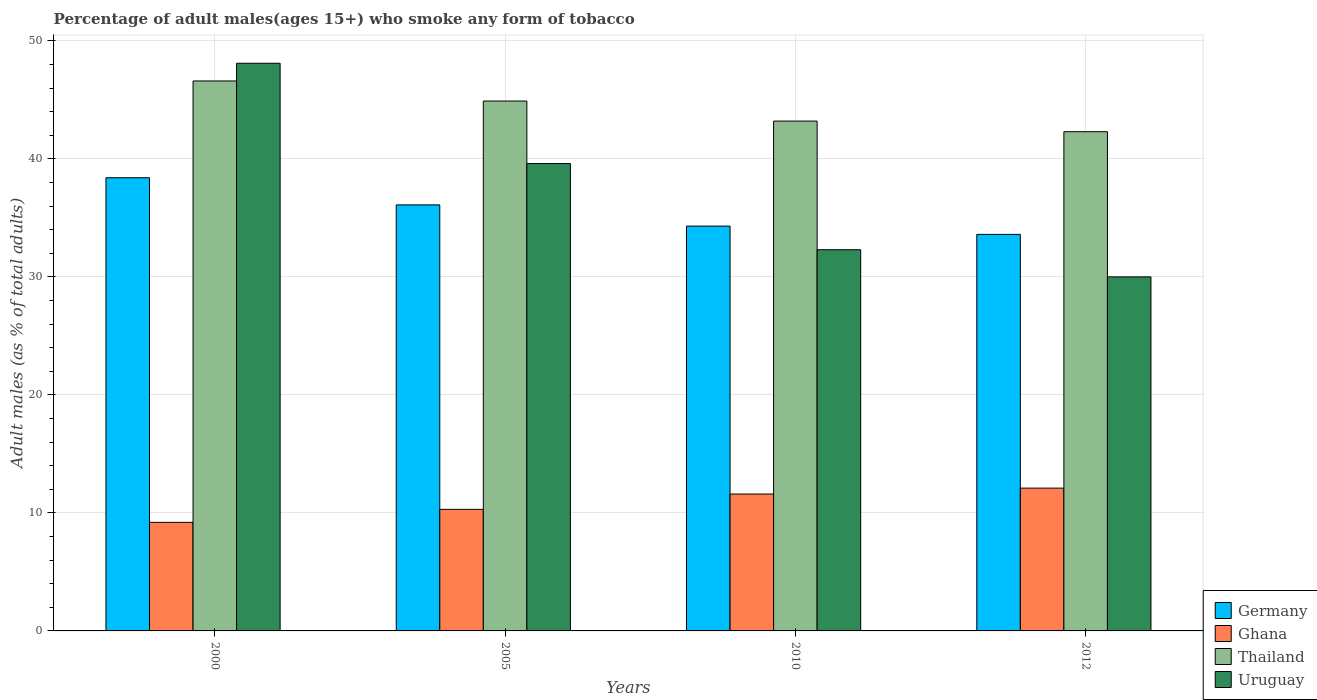How many different coloured bars are there?
Your answer should be very brief. 4. Are the number of bars per tick equal to the number of legend labels?
Your response must be concise. Yes. How many bars are there on the 1st tick from the left?
Offer a very short reply. 4. How many bars are there on the 1st tick from the right?
Make the answer very short. 4. In how many cases, is the number of bars for a given year not equal to the number of legend labels?
Keep it short and to the point. 0. What is the percentage of adult males who smoke in Germany in 2005?
Your answer should be very brief. 36.1. Across all years, what is the maximum percentage of adult males who smoke in Ghana?
Ensure brevity in your answer.  12.1. Across all years, what is the minimum percentage of adult males who smoke in Germany?
Make the answer very short. 33.6. What is the total percentage of adult males who smoke in Germany in the graph?
Offer a terse response. 142.4. What is the difference between the percentage of adult males who smoke in Uruguay in 2000 and that in 2005?
Make the answer very short. 8.5. What is the difference between the percentage of adult males who smoke in Uruguay in 2000 and the percentage of adult males who smoke in Thailand in 2012?
Keep it short and to the point. 5.8. What is the average percentage of adult males who smoke in Ghana per year?
Provide a short and direct response. 10.8. In the year 2000, what is the difference between the percentage of adult males who smoke in Thailand and percentage of adult males who smoke in Ghana?
Offer a very short reply. 37.4. In how many years, is the percentage of adult males who smoke in Thailand greater than 20 %?
Ensure brevity in your answer.  4. What is the ratio of the percentage of adult males who smoke in Germany in 2010 to that in 2012?
Ensure brevity in your answer.  1.02. Is the percentage of adult males who smoke in Ghana in 2000 less than that in 2010?
Your answer should be compact. Yes. Is the difference between the percentage of adult males who smoke in Thailand in 2005 and 2010 greater than the difference between the percentage of adult males who smoke in Ghana in 2005 and 2010?
Make the answer very short. Yes. What is the difference between the highest and the lowest percentage of adult males who smoke in Thailand?
Offer a terse response. 4.3. In how many years, is the percentage of adult males who smoke in Ghana greater than the average percentage of adult males who smoke in Ghana taken over all years?
Ensure brevity in your answer.  2. Is the sum of the percentage of adult males who smoke in Germany in 2005 and 2012 greater than the maximum percentage of adult males who smoke in Uruguay across all years?
Offer a terse response. Yes. Is it the case that in every year, the sum of the percentage of adult males who smoke in Uruguay and percentage of adult males who smoke in Thailand is greater than the sum of percentage of adult males who smoke in Ghana and percentage of adult males who smoke in Germany?
Your response must be concise. Yes. What does the 2nd bar from the right in 2005 represents?
Ensure brevity in your answer.  Thailand. Is it the case that in every year, the sum of the percentage of adult males who smoke in Germany and percentage of adult males who smoke in Thailand is greater than the percentage of adult males who smoke in Uruguay?
Give a very brief answer. Yes. How many bars are there?
Offer a terse response. 16. What is the difference between two consecutive major ticks on the Y-axis?
Provide a succinct answer. 10. Are the values on the major ticks of Y-axis written in scientific E-notation?
Your answer should be compact. No. Where does the legend appear in the graph?
Keep it short and to the point. Bottom right. What is the title of the graph?
Your response must be concise. Percentage of adult males(ages 15+) who smoke any form of tobacco. What is the label or title of the Y-axis?
Your answer should be compact. Adult males (as % of total adults). What is the Adult males (as % of total adults) of Germany in 2000?
Make the answer very short. 38.4. What is the Adult males (as % of total adults) in Ghana in 2000?
Provide a short and direct response. 9.2. What is the Adult males (as % of total adults) of Thailand in 2000?
Offer a terse response. 46.6. What is the Adult males (as % of total adults) in Uruguay in 2000?
Provide a short and direct response. 48.1. What is the Adult males (as % of total adults) of Germany in 2005?
Your answer should be very brief. 36.1. What is the Adult males (as % of total adults) of Thailand in 2005?
Offer a very short reply. 44.9. What is the Adult males (as % of total adults) of Uruguay in 2005?
Ensure brevity in your answer.  39.6. What is the Adult males (as % of total adults) of Germany in 2010?
Your answer should be very brief. 34.3. What is the Adult males (as % of total adults) in Thailand in 2010?
Give a very brief answer. 43.2. What is the Adult males (as % of total adults) of Uruguay in 2010?
Offer a very short reply. 32.3. What is the Adult males (as % of total adults) of Germany in 2012?
Keep it short and to the point. 33.6. What is the Adult males (as % of total adults) in Thailand in 2012?
Your answer should be compact. 42.3. Across all years, what is the maximum Adult males (as % of total adults) of Germany?
Offer a very short reply. 38.4. Across all years, what is the maximum Adult males (as % of total adults) of Ghana?
Offer a very short reply. 12.1. Across all years, what is the maximum Adult males (as % of total adults) of Thailand?
Your answer should be very brief. 46.6. Across all years, what is the maximum Adult males (as % of total adults) of Uruguay?
Provide a short and direct response. 48.1. Across all years, what is the minimum Adult males (as % of total adults) in Germany?
Your response must be concise. 33.6. Across all years, what is the minimum Adult males (as % of total adults) of Thailand?
Make the answer very short. 42.3. What is the total Adult males (as % of total adults) in Germany in the graph?
Your answer should be compact. 142.4. What is the total Adult males (as % of total adults) of Ghana in the graph?
Offer a very short reply. 43.2. What is the total Adult males (as % of total adults) in Thailand in the graph?
Offer a terse response. 177. What is the total Adult males (as % of total adults) of Uruguay in the graph?
Give a very brief answer. 150. What is the difference between the Adult males (as % of total adults) in Ghana in 2000 and that in 2005?
Provide a succinct answer. -1.1. What is the difference between the Adult males (as % of total adults) of Germany in 2000 and that in 2010?
Offer a terse response. 4.1. What is the difference between the Adult males (as % of total adults) of Ghana in 2000 and that in 2010?
Offer a terse response. -2.4. What is the difference between the Adult males (as % of total adults) of Thailand in 2000 and that in 2010?
Keep it short and to the point. 3.4. What is the difference between the Adult males (as % of total adults) of Uruguay in 2000 and that in 2010?
Your answer should be compact. 15.8. What is the difference between the Adult males (as % of total adults) in Germany in 2000 and that in 2012?
Your answer should be compact. 4.8. What is the difference between the Adult males (as % of total adults) of Ghana in 2000 and that in 2012?
Provide a succinct answer. -2.9. What is the difference between the Adult males (as % of total adults) in Thailand in 2000 and that in 2012?
Your answer should be very brief. 4.3. What is the difference between the Adult males (as % of total adults) in Germany in 2005 and that in 2010?
Provide a succinct answer. 1.8. What is the difference between the Adult males (as % of total adults) of Thailand in 2005 and that in 2010?
Provide a succinct answer. 1.7. What is the difference between the Adult males (as % of total adults) in Uruguay in 2005 and that in 2010?
Offer a very short reply. 7.3. What is the difference between the Adult males (as % of total adults) of Germany in 2005 and that in 2012?
Offer a very short reply. 2.5. What is the difference between the Adult males (as % of total adults) of Ghana in 2005 and that in 2012?
Make the answer very short. -1.8. What is the difference between the Adult males (as % of total adults) of Germany in 2010 and that in 2012?
Provide a succinct answer. 0.7. What is the difference between the Adult males (as % of total adults) in Uruguay in 2010 and that in 2012?
Give a very brief answer. 2.3. What is the difference between the Adult males (as % of total adults) of Germany in 2000 and the Adult males (as % of total adults) of Ghana in 2005?
Ensure brevity in your answer.  28.1. What is the difference between the Adult males (as % of total adults) of Ghana in 2000 and the Adult males (as % of total adults) of Thailand in 2005?
Your answer should be compact. -35.7. What is the difference between the Adult males (as % of total adults) of Ghana in 2000 and the Adult males (as % of total adults) of Uruguay in 2005?
Give a very brief answer. -30.4. What is the difference between the Adult males (as % of total adults) of Thailand in 2000 and the Adult males (as % of total adults) of Uruguay in 2005?
Offer a terse response. 7. What is the difference between the Adult males (as % of total adults) of Germany in 2000 and the Adult males (as % of total adults) of Ghana in 2010?
Provide a succinct answer. 26.8. What is the difference between the Adult males (as % of total adults) in Germany in 2000 and the Adult males (as % of total adults) in Thailand in 2010?
Give a very brief answer. -4.8. What is the difference between the Adult males (as % of total adults) of Germany in 2000 and the Adult males (as % of total adults) of Uruguay in 2010?
Provide a succinct answer. 6.1. What is the difference between the Adult males (as % of total adults) in Ghana in 2000 and the Adult males (as % of total adults) in Thailand in 2010?
Provide a short and direct response. -34. What is the difference between the Adult males (as % of total adults) in Ghana in 2000 and the Adult males (as % of total adults) in Uruguay in 2010?
Provide a short and direct response. -23.1. What is the difference between the Adult males (as % of total adults) of Germany in 2000 and the Adult males (as % of total adults) of Ghana in 2012?
Keep it short and to the point. 26.3. What is the difference between the Adult males (as % of total adults) of Germany in 2000 and the Adult males (as % of total adults) of Uruguay in 2012?
Your response must be concise. 8.4. What is the difference between the Adult males (as % of total adults) of Ghana in 2000 and the Adult males (as % of total adults) of Thailand in 2012?
Keep it short and to the point. -33.1. What is the difference between the Adult males (as % of total adults) of Ghana in 2000 and the Adult males (as % of total adults) of Uruguay in 2012?
Ensure brevity in your answer.  -20.8. What is the difference between the Adult males (as % of total adults) in Thailand in 2000 and the Adult males (as % of total adults) in Uruguay in 2012?
Your answer should be compact. 16.6. What is the difference between the Adult males (as % of total adults) of Germany in 2005 and the Adult males (as % of total adults) of Ghana in 2010?
Give a very brief answer. 24.5. What is the difference between the Adult males (as % of total adults) of Germany in 2005 and the Adult males (as % of total adults) of Uruguay in 2010?
Keep it short and to the point. 3.8. What is the difference between the Adult males (as % of total adults) in Ghana in 2005 and the Adult males (as % of total adults) in Thailand in 2010?
Give a very brief answer. -32.9. What is the difference between the Adult males (as % of total adults) in Ghana in 2005 and the Adult males (as % of total adults) in Uruguay in 2010?
Provide a short and direct response. -22. What is the difference between the Adult males (as % of total adults) in Thailand in 2005 and the Adult males (as % of total adults) in Uruguay in 2010?
Keep it short and to the point. 12.6. What is the difference between the Adult males (as % of total adults) of Germany in 2005 and the Adult males (as % of total adults) of Ghana in 2012?
Give a very brief answer. 24. What is the difference between the Adult males (as % of total adults) of Germany in 2005 and the Adult males (as % of total adults) of Thailand in 2012?
Provide a succinct answer. -6.2. What is the difference between the Adult males (as % of total adults) of Germany in 2005 and the Adult males (as % of total adults) of Uruguay in 2012?
Ensure brevity in your answer.  6.1. What is the difference between the Adult males (as % of total adults) in Ghana in 2005 and the Adult males (as % of total adults) in Thailand in 2012?
Provide a short and direct response. -32. What is the difference between the Adult males (as % of total adults) of Ghana in 2005 and the Adult males (as % of total adults) of Uruguay in 2012?
Your response must be concise. -19.7. What is the difference between the Adult males (as % of total adults) of Germany in 2010 and the Adult males (as % of total adults) of Ghana in 2012?
Ensure brevity in your answer.  22.2. What is the difference between the Adult males (as % of total adults) in Germany in 2010 and the Adult males (as % of total adults) in Uruguay in 2012?
Give a very brief answer. 4.3. What is the difference between the Adult males (as % of total adults) of Ghana in 2010 and the Adult males (as % of total adults) of Thailand in 2012?
Your answer should be very brief. -30.7. What is the difference between the Adult males (as % of total adults) in Ghana in 2010 and the Adult males (as % of total adults) in Uruguay in 2012?
Give a very brief answer. -18.4. What is the average Adult males (as % of total adults) of Germany per year?
Ensure brevity in your answer.  35.6. What is the average Adult males (as % of total adults) in Ghana per year?
Your answer should be compact. 10.8. What is the average Adult males (as % of total adults) of Thailand per year?
Make the answer very short. 44.25. What is the average Adult males (as % of total adults) in Uruguay per year?
Give a very brief answer. 37.5. In the year 2000, what is the difference between the Adult males (as % of total adults) of Germany and Adult males (as % of total adults) of Ghana?
Give a very brief answer. 29.2. In the year 2000, what is the difference between the Adult males (as % of total adults) of Germany and Adult males (as % of total adults) of Thailand?
Your answer should be compact. -8.2. In the year 2000, what is the difference between the Adult males (as % of total adults) of Germany and Adult males (as % of total adults) of Uruguay?
Offer a terse response. -9.7. In the year 2000, what is the difference between the Adult males (as % of total adults) of Ghana and Adult males (as % of total adults) of Thailand?
Offer a very short reply. -37.4. In the year 2000, what is the difference between the Adult males (as % of total adults) of Ghana and Adult males (as % of total adults) of Uruguay?
Keep it short and to the point. -38.9. In the year 2000, what is the difference between the Adult males (as % of total adults) in Thailand and Adult males (as % of total adults) in Uruguay?
Offer a terse response. -1.5. In the year 2005, what is the difference between the Adult males (as % of total adults) in Germany and Adult males (as % of total adults) in Ghana?
Your answer should be very brief. 25.8. In the year 2005, what is the difference between the Adult males (as % of total adults) in Germany and Adult males (as % of total adults) in Uruguay?
Provide a short and direct response. -3.5. In the year 2005, what is the difference between the Adult males (as % of total adults) of Ghana and Adult males (as % of total adults) of Thailand?
Give a very brief answer. -34.6. In the year 2005, what is the difference between the Adult males (as % of total adults) of Ghana and Adult males (as % of total adults) of Uruguay?
Provide a short and direct response. -29.3. In the year 2005, what is the difference between the Adult males (as % of total adults) in Thailand and Adult males (as % of total adults) in Uruguay?
Keep it short and to the point. 5.3. In the year 2010, what is the difference between the Adult males (as % of total adults) in Germany and Adult males (as % of total adults) in Ghana?
Provide a succinct answer. 22.7. In the year 2010, what is the difference between the Adult males (as % of total adults) of Germany and Adult males (as % of total adults) of Thailand?
Offer a terse response. -8.9. In the year 2010, what is the difference between the Adult males (as % of total adults) of Ghana and Adult males (as % of total adults) of Thailand?
Provide a succinct answer. -31.6. In the year 2010, what is the difference between the Adult males (as % of total adults) of Ghana and Adult males (as % of total adults) of Uruguay?
Provide a short and direct response. -20.7. In the year 2010, what is the difference between the Adult males (as % of total adults) of Thailand and Adult males (as % of total adults) of Uruguay?
Make the answer very short. 10.9. In the year 2012, what is the difference between the Adult males (as % of total adults) of Germany and Adult males (as % of total adults) of Uruguay?
Your answer should be compact. 3.6. In the year 2012, what is the difference between the Adult males (as % of total adults) of Ghana and Adult males (as % of total adults) of Thailand?
Keep it short and to the point. -30.2. In the year 2012, what is the difference between the Adult males (as % of total adults) in Ghana and Adult males (as % of total adults) in Uruguay?
Provide a short and direct response. -17.9. What is the ratio of the Adult males (as % of total adults) in Germany in 2000 to that in 2005?
Ensure brevity in your answer.  1.06. What is the ratio of the Adult males (as % of total adults) of Ghana in 2000 to that in 2005?
Provide a short and direct response. 0.89. What is the ratio of the Adult males (as % of total adults) of Thailand in 2000 to that in 2005?
Provide a succinct answer. 1.04. What is the ratio of the Adult males (as % of total adults) of Uruguay in 2000 to that in 2005?
Offer a terse response. 1.21. What is the ratio of the Adult males (as % of total adults) of Germany in 2000 to that in 2010?
Your answer should be very brief. 1.12. What is the ratio of the Adult males (as % of total adults) in Ghana in 2000 to that in 2010?
Your response must be concise. 0.79. What is the ratio of the Adult males (as % of total adults) in Thailand in 2000 to that in 2010?
Your response must be concise. 1.08. What is the ratio of the Adult males (as % of total adults) of Uruguay in 2000 to that in 2010?
Your response must be concise. 1.49. What is the ratio of the Adult males (as % of total adults) in Ghana in 2000 to that in 2012?
Your answer should be very brief. 0.76. What is the ratio of the Adult males (as % of total adults) in Thailand in 2000 to that in 2012?
Your answer should be very brief. 1.1. What is the ratio of the Adult males (as % of total adults) of Uruguay in 2000 to that in 2012?
Ensure brevity in your answer.  1.6. What is the ratio of the Adult males (as % of total adults) in Germany in 2005 to that in 2010?
Your response must be concise. 1.05. What is the ratio of the Adult males (as % of total adults) in Ghana in 2005 to that in 2010?
Your answer should be compact. 0.89. What is the ratio of the Adult males (as % of total adults) of Thailand in 2005 to that in 2010?
Give a very brief answer. 1.04. What is the ratio of the Adult males (as % of total adults) in Uruguay in 2005 to that in 2010?
Offer a terse response. 1.23. What is the ratio of the Adult males (as % of total adults) of Germany in 2005 to that in 2012?
Offer a terse response. 1.07. What is the ratio of the Adult males (as % of total adults) in Ghana in 2005 to that in 2012?
Provide a short and direct response. 0.85. What is the ratio of the Adult males (as % of total adults) in Thailand in 2005 to that in 2012?
Your answer should be compact. 1.06. What is the ratio of the Adult males (as % of total adults) in Uruguay in 2005 to that in 2012?
Your answer should be compact. 1.32. What is the ratio of the Adult males (as % of total adults) in Germany in 2010 to that in 2012?
Provide a succinct answer. 1.02. What is the ratio of the Adult males (as % of total adults) in Ghana in 2010 to that in 2012?
Provide a succinct answer. 0.96. What is the ratio of the Adult males (as % of total adults) of Thailand in 2010 to that in 2012?
Offer a very short reply. 1.02. What is the ratio of the Adult males (as % of total adults) in Uruguay in 2010 to that in 2012?
Provide a short and direct response. 1.08. What is the difference between the highest and the second highest Adult males (as % of total adults) in Ghana?
Your response must be concise. 0.5. What is the difference between the highest and the second highest Adult males (as % of total adults) in Uruguay?
Make the answer very short. 8.5. What is the difference between the highest and the lowest Adult males (as % of total adults) in Thailand?
Ensure brevity in your answer.  4.3. 